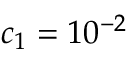Convert formula to latex. <formula><loc_0><loc_0><loc_500><loc_500>c _ { 1 } = 1 0 ^ { - 2 }</formula> 